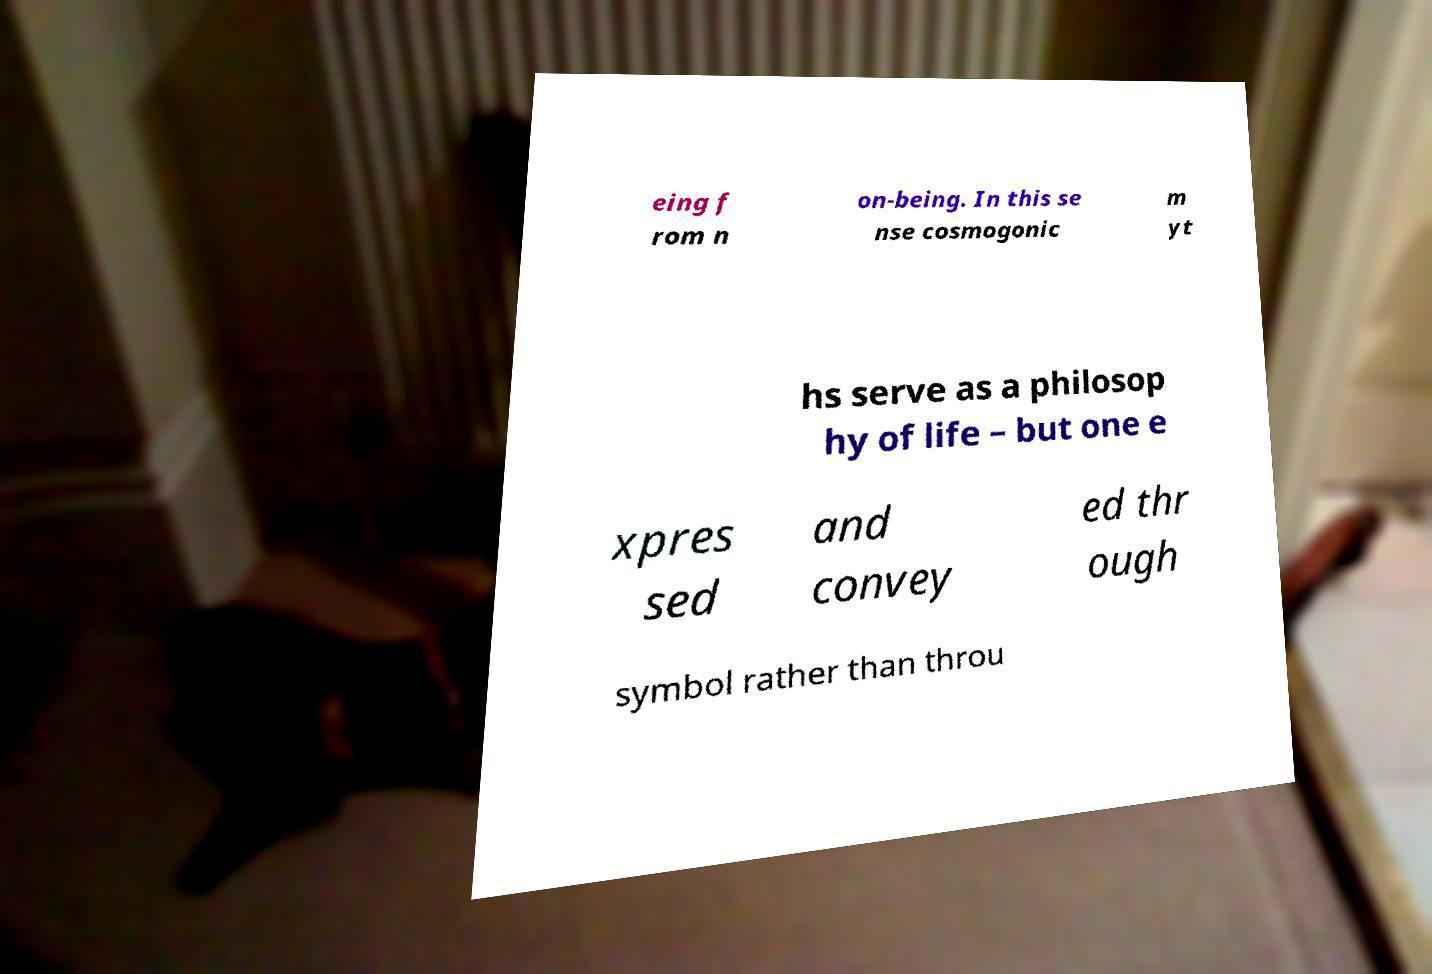Could you extract and type out the text from this image? eing f rom n on-being. In this se nse cosmogonic m yt hs serve as a philosop hy of life – but one e xpres sed and convey ed thr ough symbol rather than throu 